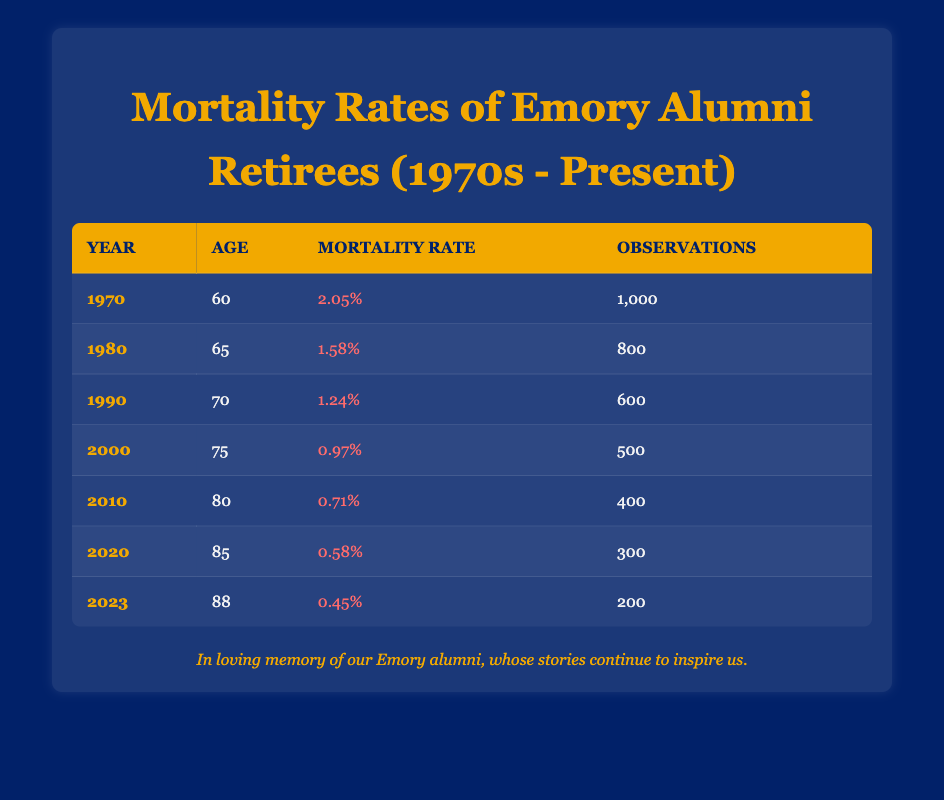What is the mortality rate for retirees in 1980? From the table, we can see that in the year 1980, the mortality rate is listed in the corresponding row. The mortality rate is 1.58%.
Answer: 1.58% How many observations were there for retirees in 2000? The table provides the number of observations for each year. In the year 2000, the number of observations is 500.
Answer: 500 What was the decrease in mortality rate from 1970 to 2023? To find the decrease, we need to subtract the mortality rate of 2023 from that of 1970. Thus, 2.05% (1970) - 0.45% (2023) = 1.60%.
Answer: 1.60% True or False: The mortality rate has consistently decreased from 1970 to 2020. Looking at the table, we see that the mortality rates for each decade from 1970 (2.05%) to 2020 (0.58%) show a consistent decline. Thus, it is true.
Answer: True What is the average mortality rate for retirees aged 75 and older from 2000 to 2023? We will consider the years 2000 (0.97%), 2010 (0.71%), 2020 (0.58%), and 2023 (0.45%). Calculating the average: (0.97% + 0.71% + 0.58% + 0.45%) / 4 = 0.715%.
Answer: 0.715% What year had the lowest mortality rate for retirees aged 85? The table shows data for the year 2020 (0.58%) and 2023 (0.45%), where the lowest rate corresponds to 2023.
Answer: 2023 Which age group showed the greatest reduction in mortality rate from 1990 to 2010? The mortality rates for 1990 (1.24% at age 70) and 2010 (0.71% at age 80). The age group calculated indicates that the greatest reduction is 1.24% - 0.71% = 0.53%.
Answer: Age 70 to 80 What is the total number of observations recorded for retirees from 1970 to 2023? To find the total observations, we add together the observations for each year: 1000 + 800 + 600 + 500 + 400 + 300 + 200 = 3800.
Answer: 3800 